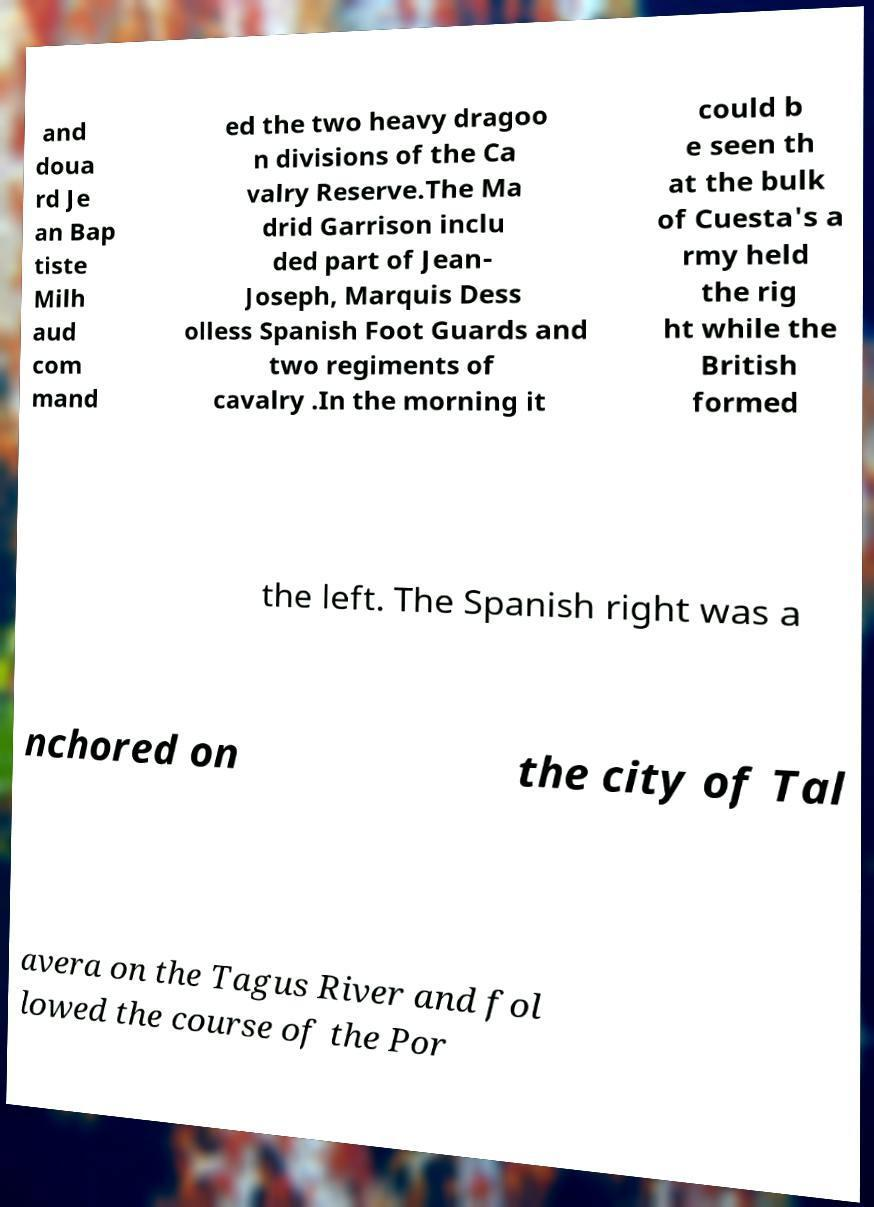Please identify and transcribe the text found in this image. and doua rd Je an Bap tiste Milh aud com mand ed the two heavy dragoo n divisions of the Ca valry Reserve.The Ma drid Garrison inclu ded part of Jean- Joseph, Marquis Dess olless Spanish Foot Guards and two regiments of cavalry .In the morning it could b e seen th at the bulk of Cuesta's a rmy held the rig ht while the British formed the left. The Spanish right was a nchored on the city of Tal avera on the Tagus River and fol lowed the course of the Por 